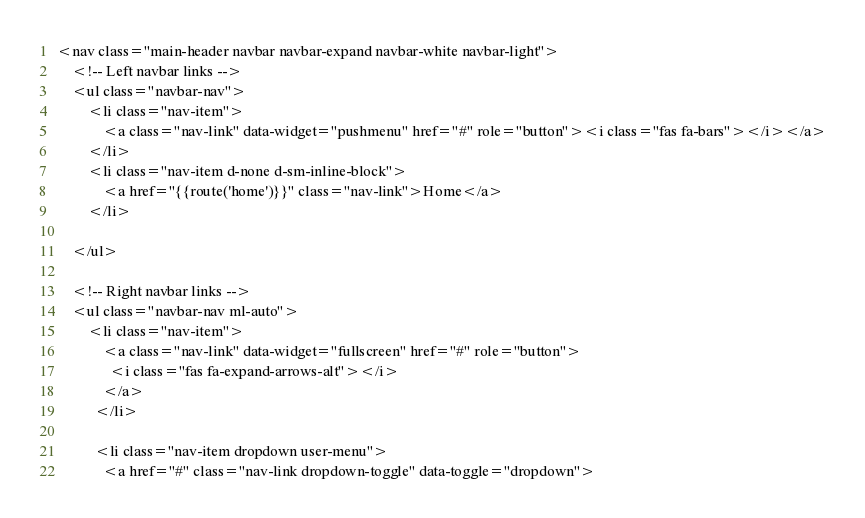<code> <loc_0><loc_0><loc_500><loc_500><_PHP_><nav class="main-header navbar navbar-expand navbar-white navbar-light">
    <!-- Left navbar links -->
    <ul class="navbar-nav">
        <li class="nav-item">
            <a class="nav-link" data-widget="pushmenu" href="#" role="button"><i class="fas fa-bars"></i></a>
        </li>
        <li class="nav-item d-none d-sm-inline-block">
            <a href="{{route('home')}}" class="nav-link">Home</a>
        </li>

    </ul>

    <!-- Right navbar links -->
    <ul class="navbar-nav ml-auto">
        <li class="nav-item">
            <a class="nav-link" data-widget="fullscreen" href="#" role="button">
              <i class="fas fa-expand-arrows-alt"></i>
            </a>
          </li>

          <li class="nav-item dropdown user-menu">
            <a href="#" class="nav-link dropdown-toggle" data-toggle="dropdown"></code> 